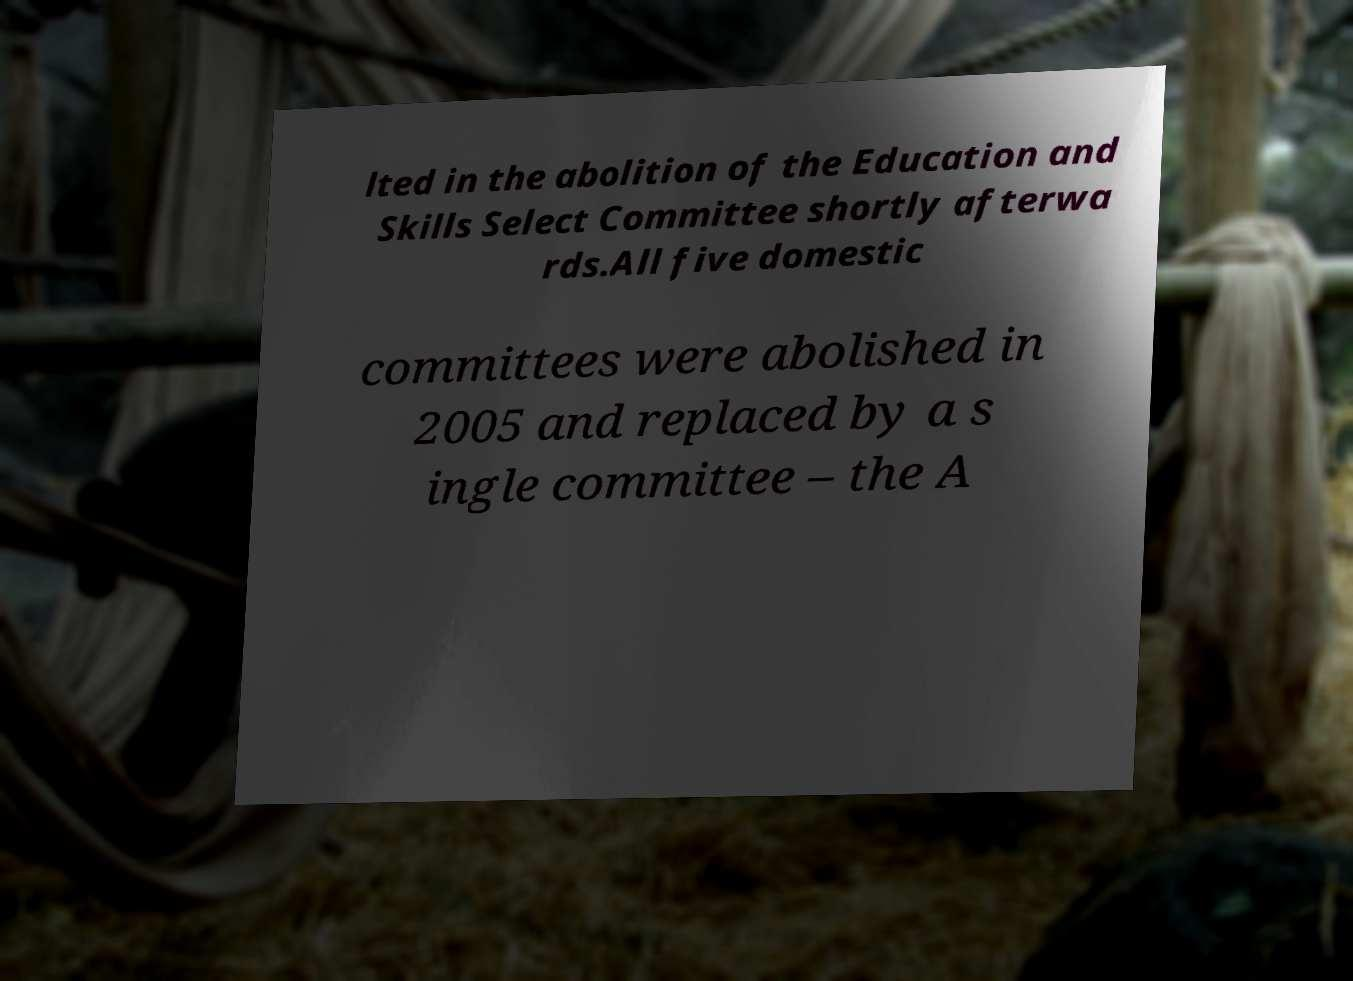Please read and relay the text visible in this image. What does it say? lted in the abolition of the Education and Skills Select Committee shortly afterwa rds.All five domestic committees were abolished in 2005 and replaced by a s ingle committee – the A 